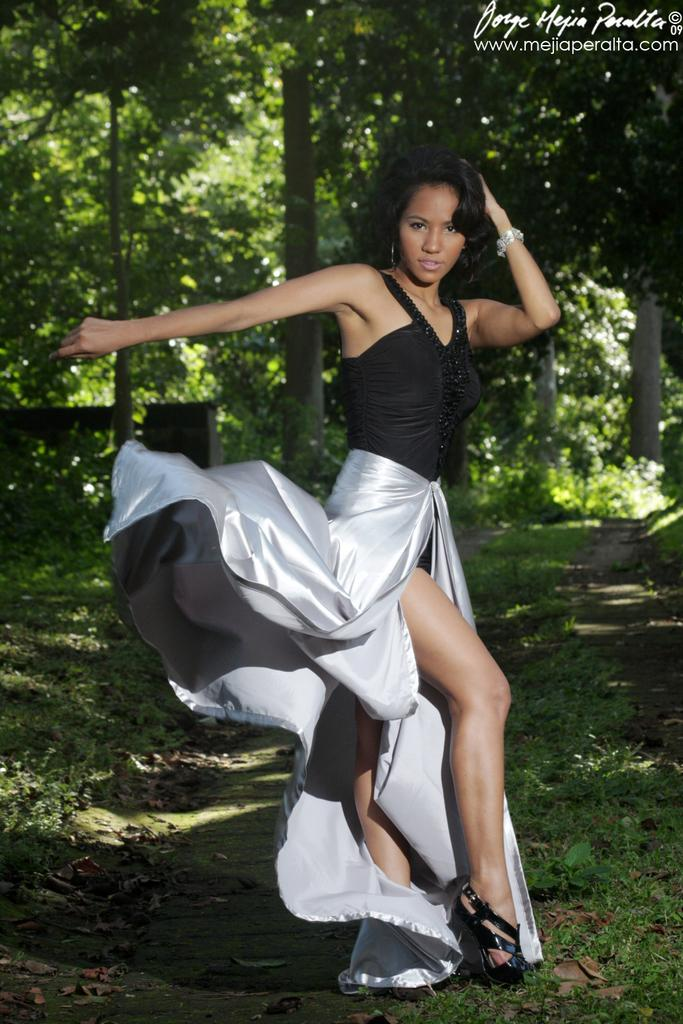Who is present in the image? There is a woman in the image. What is the woman doing in the image? The woman is standing. What is the woman wearing in the image? The woman is wearing a black top and a white color frock. What can be seen in the background of the image? There are trees visible at the back side of the image. What is present at the top of the image? There is a watermark at the top of the image. What historical event is being commemorated in the image? There is no indication of a historical event being commemorated in the image; it simply features a woman standing and wearing specific clothing. 